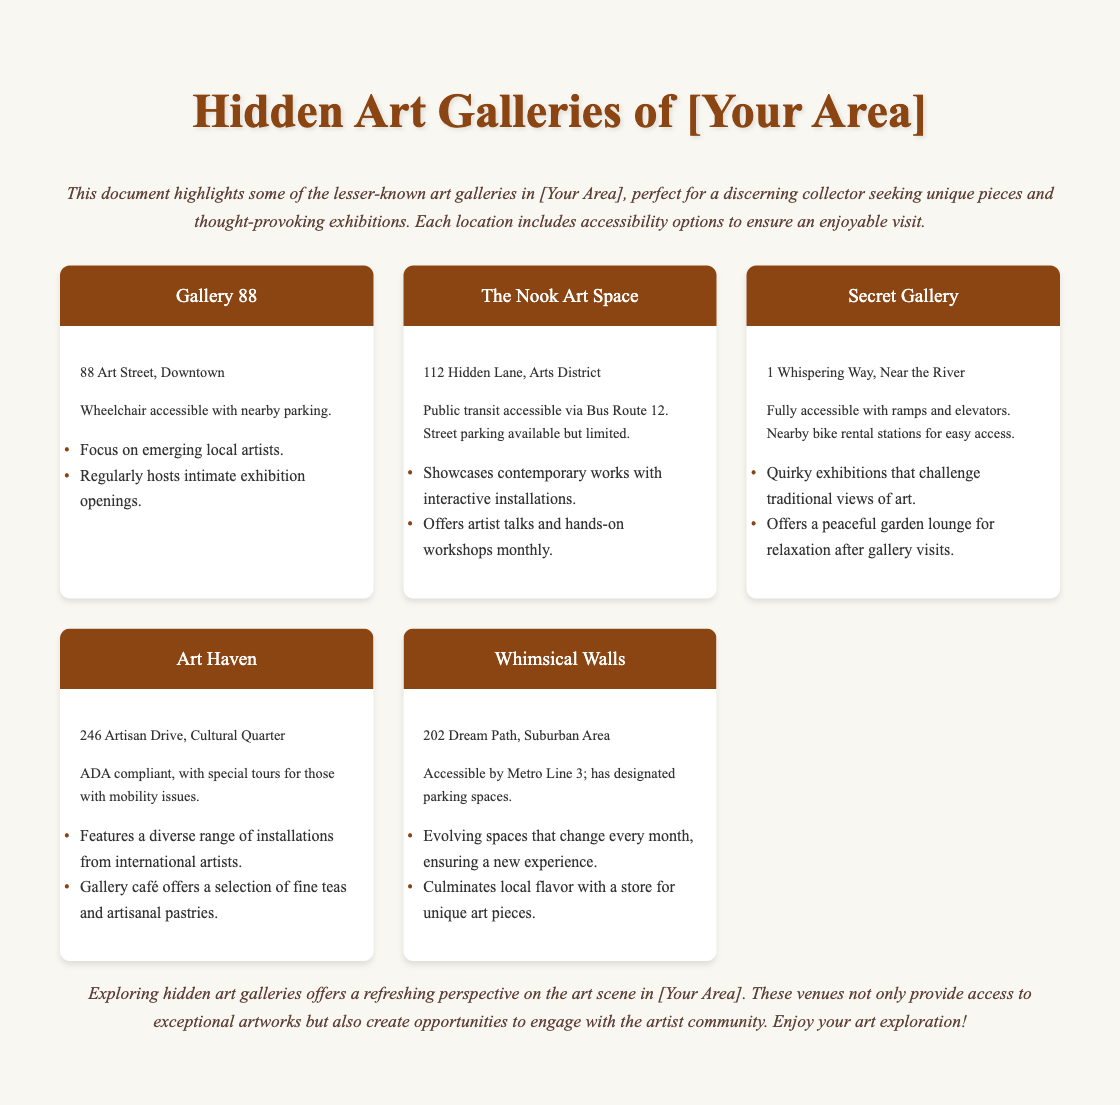what is the location of Gallery 88? The document specifies the location of Gallery 88 as "88 Art Street, Downtown."
Answer: 88 Art Street, Downtown what type of events does The Nook Art Space offer? The document mentions that The Nook Art Space offers "artist talks and hands-on workshops monthly."
Answer: artist talks and hands-on workshops how many art galleries are mentioned in the document? The document lists a total of five galleries in the hidden art section.
Answer: five which gallery features a café? The document states that "Art Haven" has a gallery café offering fine teas and artisanal pastries.
Answer: Art Haven is Secret Gallery accessible for individuals with mobility issues? The document details that Secret Gallery is "fully accessible with ramps and elevators."
Answer: yes what is the focus of exhibitions at Gallery 88? According to the document, Gallery 88 focuses on "emerging local artists."
Answer: emerging local artists where is Whimsical Walls located? The document lists the location of Whimsical Walls as "202 Dream Path, Suburban Area."
Answer: 202 Dream Path, Suburban Area what accessibility option does Art Haven offer for those with mobility issues? The document indicates that Art Haven is "ADA compliant, with special tours for those with mobility issues."
Answer: special tours for those with mobility issues which gallery is located in the Cultural Quarter? The document identifies "Art Haven" as being located in the Cultural Quarter.
Answer: Art Haven 